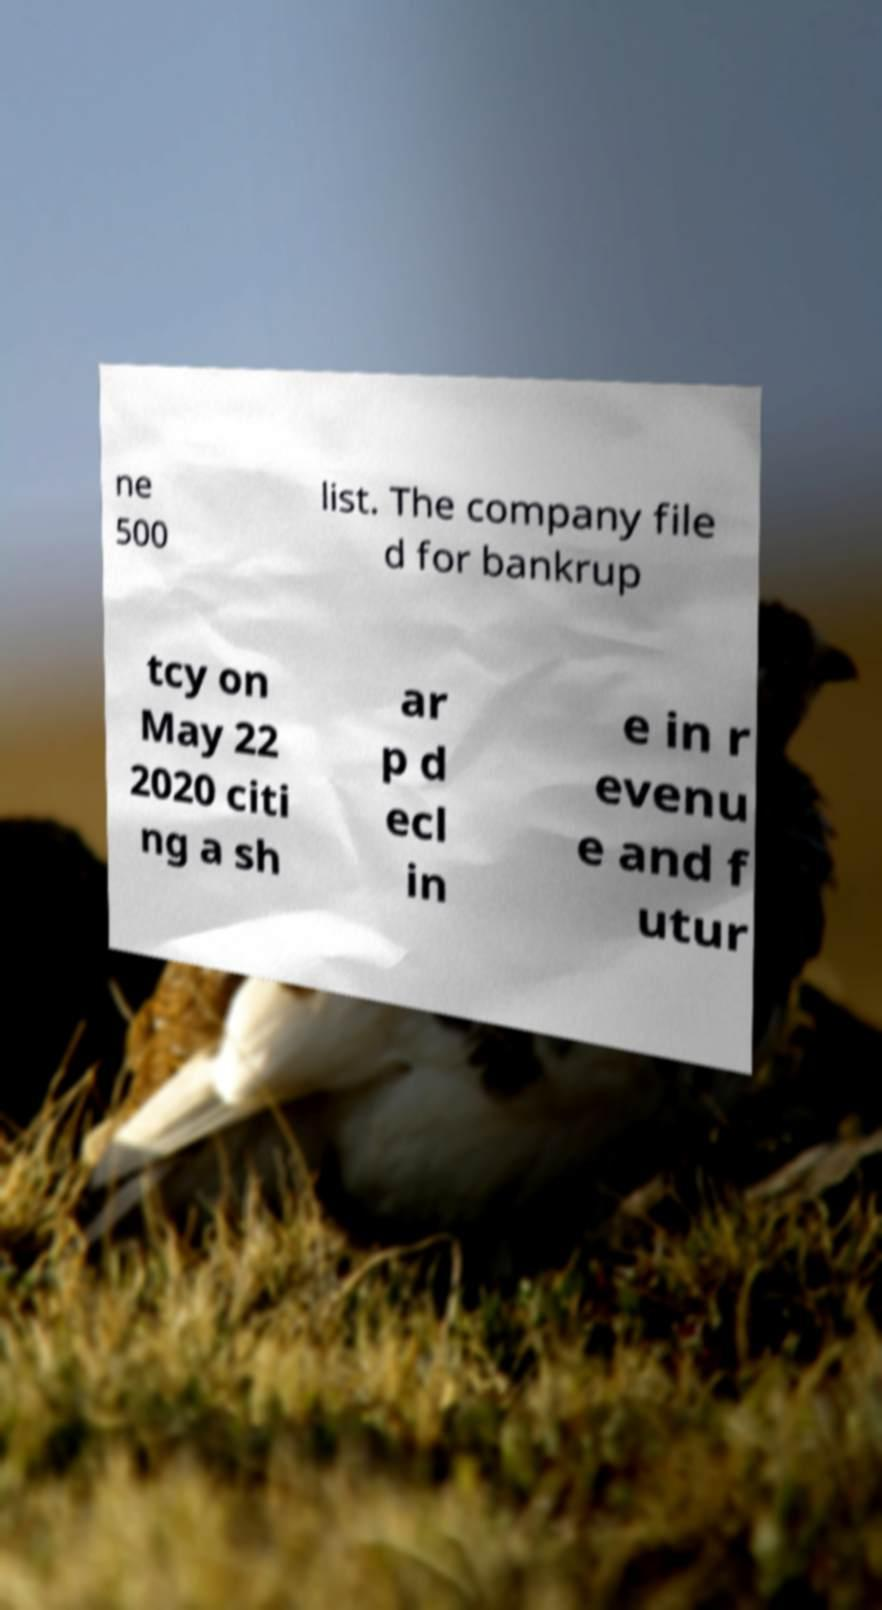Can you accurately transcribe the text from the provided image for me? ne 500 list. The company file d for bankrup tcy on May 22 2020 citi ng a sh ar p d ecl in e in r evenu e and f utur 